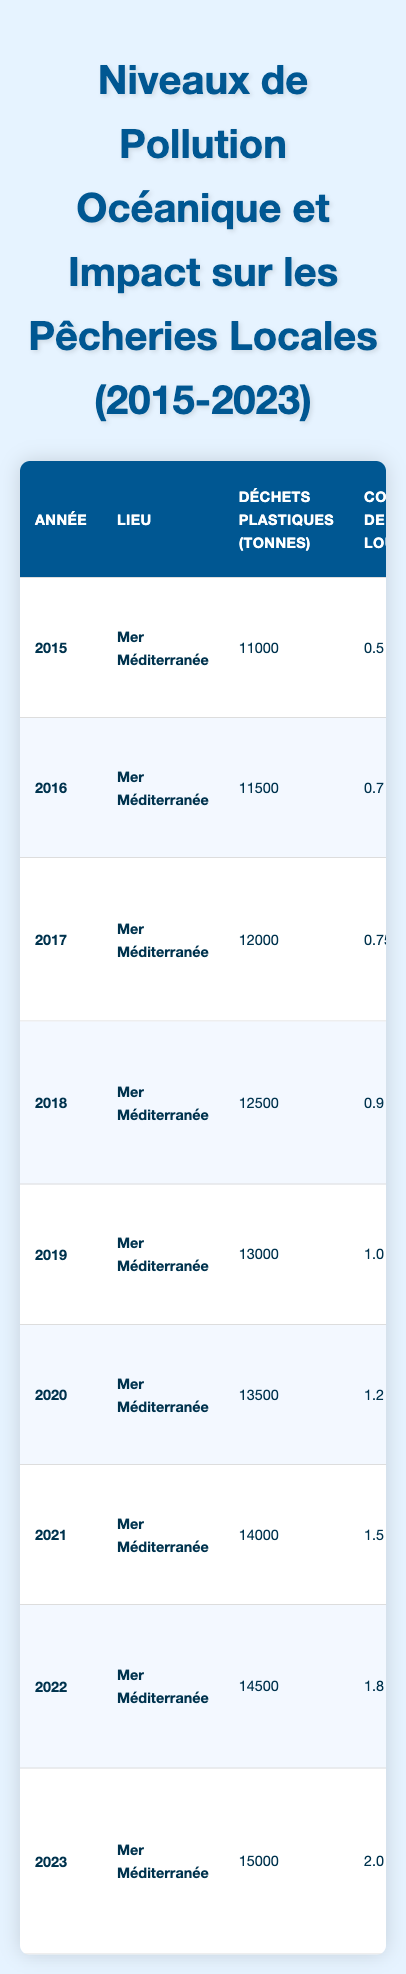What was the fish catch volume in 2020? From the table, we can see the fish catch volume for the year 2020 is listed as 11,500 tons.
Answer: 11,500 tons What was the concentration of heavy metals in 2019? The data for 2019 shows the concentration of heavy metals is 1.0 mg/L.
Answer: 1.0 mg/L In which year was the impact on local fisheries described as a "severe decline"? The table indicates that in 2022, the impact on local fisheries was described as a "severe decline observed."
Answer: 2022 How much did the plastic waste increase from 2015 to 2023? In 2015, plastic waste was 11,000 tons and in 2023 it increased to 15,000 tons. The increase is 15,000 - 11,000 = 4,000 tons.
Answer: 4,000 tons What was the average fish catch volume from 2015 to 2023? Adding the fish catch volumes from each year: 15,000 + 14,000 + 13,000 + 12,500 + 12,000 + 11,000 + 10,000 + 9,500 = 96,000 tons. Dividing by 9 years, the average is 96,000 / 9 ≈ 10,667 tons.
Answer: Approximately 10,667 tons Did the concentration of BPA increase or decrease from 2015 to 2023? In 2015, the concentration of BPA was 0.01 mg/L and in 2023 it was 0.07 mg/L. Therefore, it increased over the years.
Answer: Increase Which year had the highest recorded levels of plastic waste? Looking at the table, 2023 had the highest recorded levels of plastic waste at 15,000 tons.
Answer: 2023 What is the total decrease in fish catch volume from 2015 to 2023? The fish catch volume decreased from 15,000 tons in 2015 to 9,500 tons in 2023. The total decrease is 15,000 - 9,500 = 5,500 tons.
Answer: 5,500 tons In what year did the impact on fisheries first mention "economic strain"? The table specifies that economic strain was first mentioned in 2019 regarding the impact on fisheries.
Answer: 2019 How many years recorded a decline in fish populations? The years 2016, 2017, 2018, 2019, 2020, 2021, 2022, and 2023 all recorded some form of decline in fish populations, totaling 8 years.
Answer: 8 years 